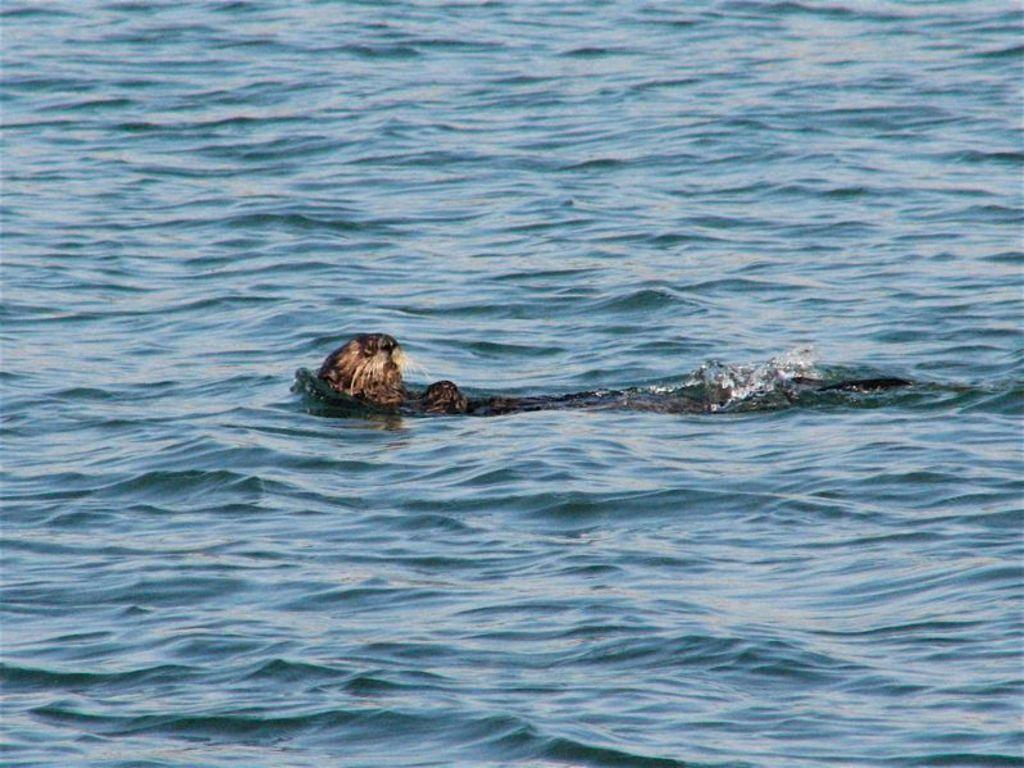What type of creature is in the image? There is an animal in the image. What color is the animal? The animal is brown in color. Where is the animal located in the image? The animal is in the water. What type of butter is being used by the animal in the image? There is no butter present in the image, as the animal is in the water and not using any butter. 